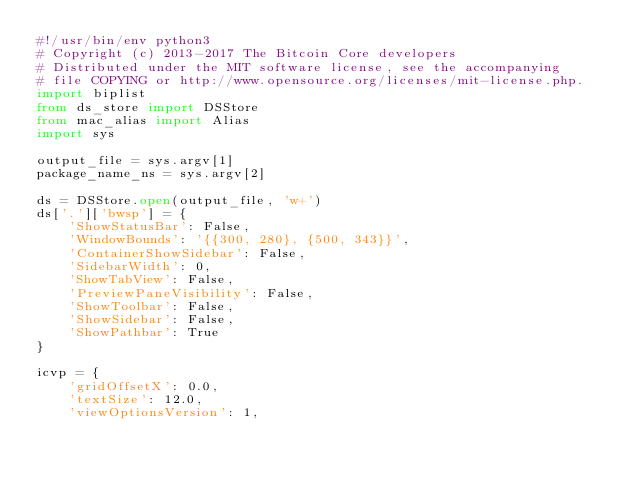Convert code to text. <code><loc_0><loc_0><loc_500><loc_500><_Python_>#!/usr/bin/env python3
# Copyright (c) 2013-2017 The Bitcoin Core developers
# Distributed under the MIT software license, see the accompanying
# file COPYING or http://www.opensource.org/licenses/mit-license.php.
import biplist
from ds_store import DSStore
from mac_alias import Alias
import sys

output_file = sys.argv[1]
package_name_ns = sys.argv[2]

ds = DSStore.open(output_file, 'w+')
ds['.']['bwsp'] = {
    'ShowStatusBar': False,
    'WindowBounds': '{{300, 280}, {500, 343}}',
    'ContainerShowSidebar': False,
    'SidebarWidth': 0,
    'ShowTabView': False,
    'PreviewPaneVisibility': False,
    'ShowToolbar': False,
    'ShowSidebar': False,
    'ShowPathbar': True
}

icvp = {
    'gridOffsetX': 0.0,
    'textSize': 12.0,
    'viewOptionsVersion': 1,</code> 